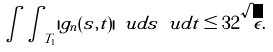Convert formula to latex. <formula><loc_0><loc_0><loc_500><loc_500>\int \int _ { T _ { 1 } } | g _ { n } ( s , t ) | \ u d s \ u d t \leq 3 2 \sqrt { \epsilon } .</formula> 